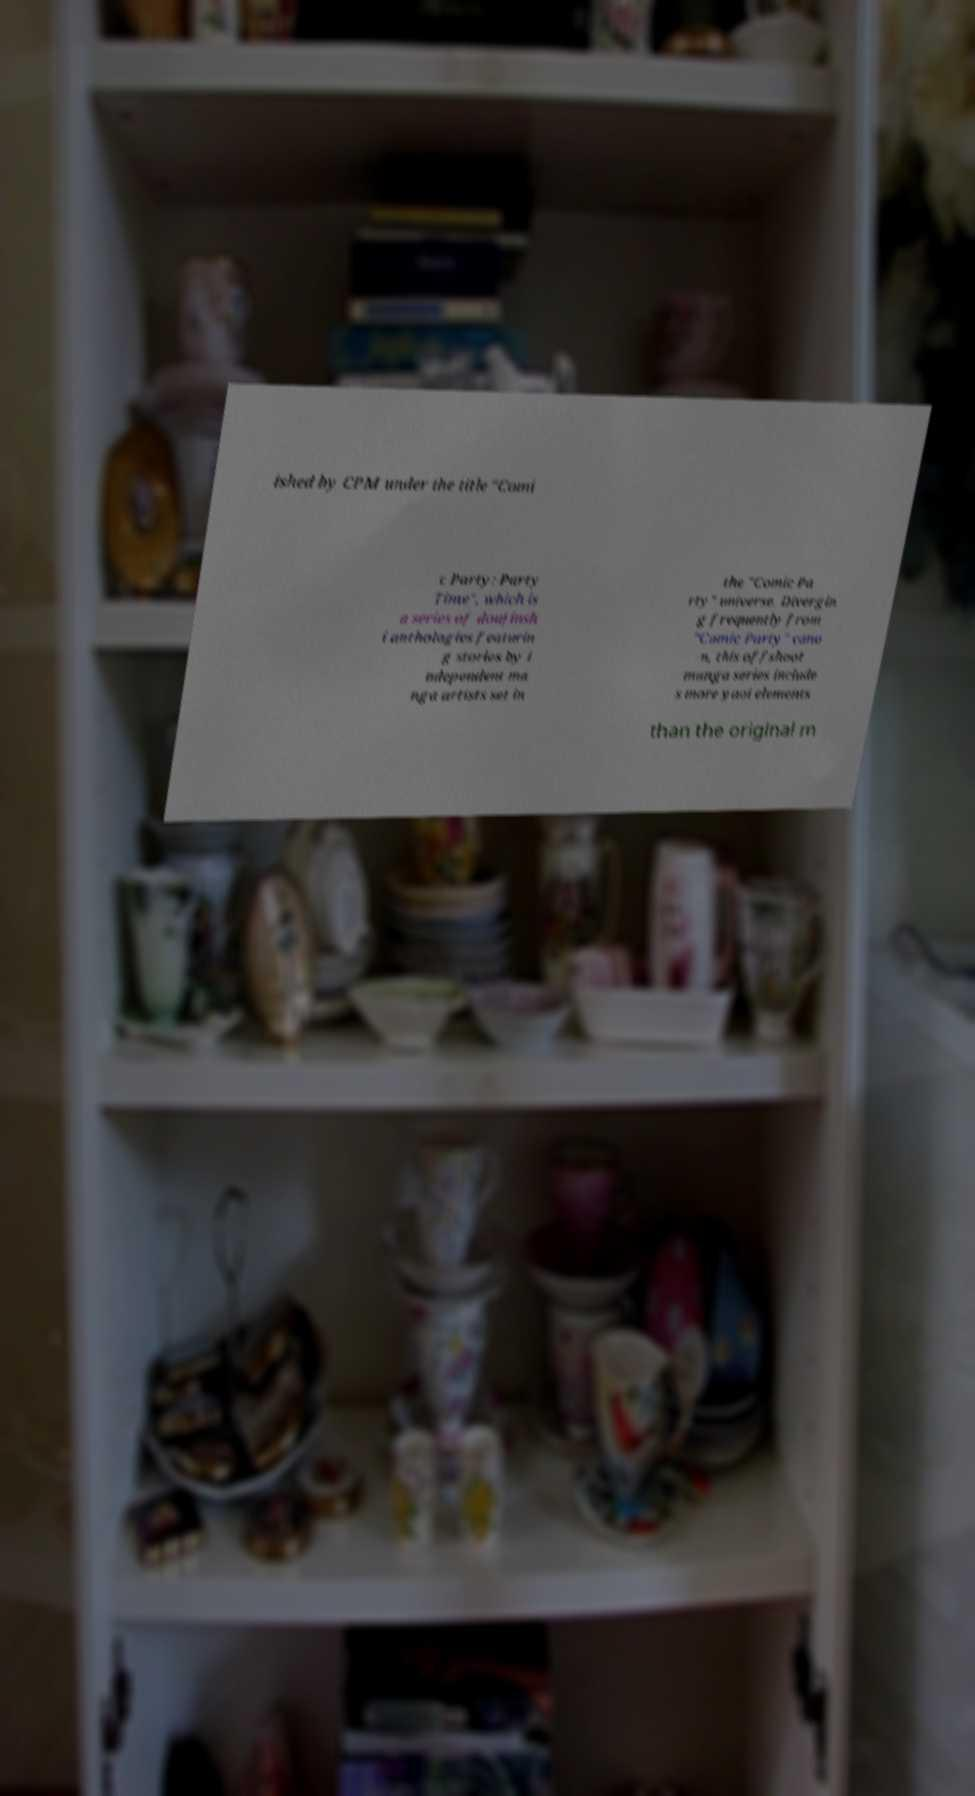Please identify and transcribe the text found in this image. ished by CPM under the title "Comi c Party: Party Time", which is a series of doujinsh i anthologies featurin g stories by i ndependent ma nga artists set in the "Comic Pa rty" universe. Divergin g frequently from "Comic Party" cano n, this offshoot manga series include s more yaoi elements than the original m 